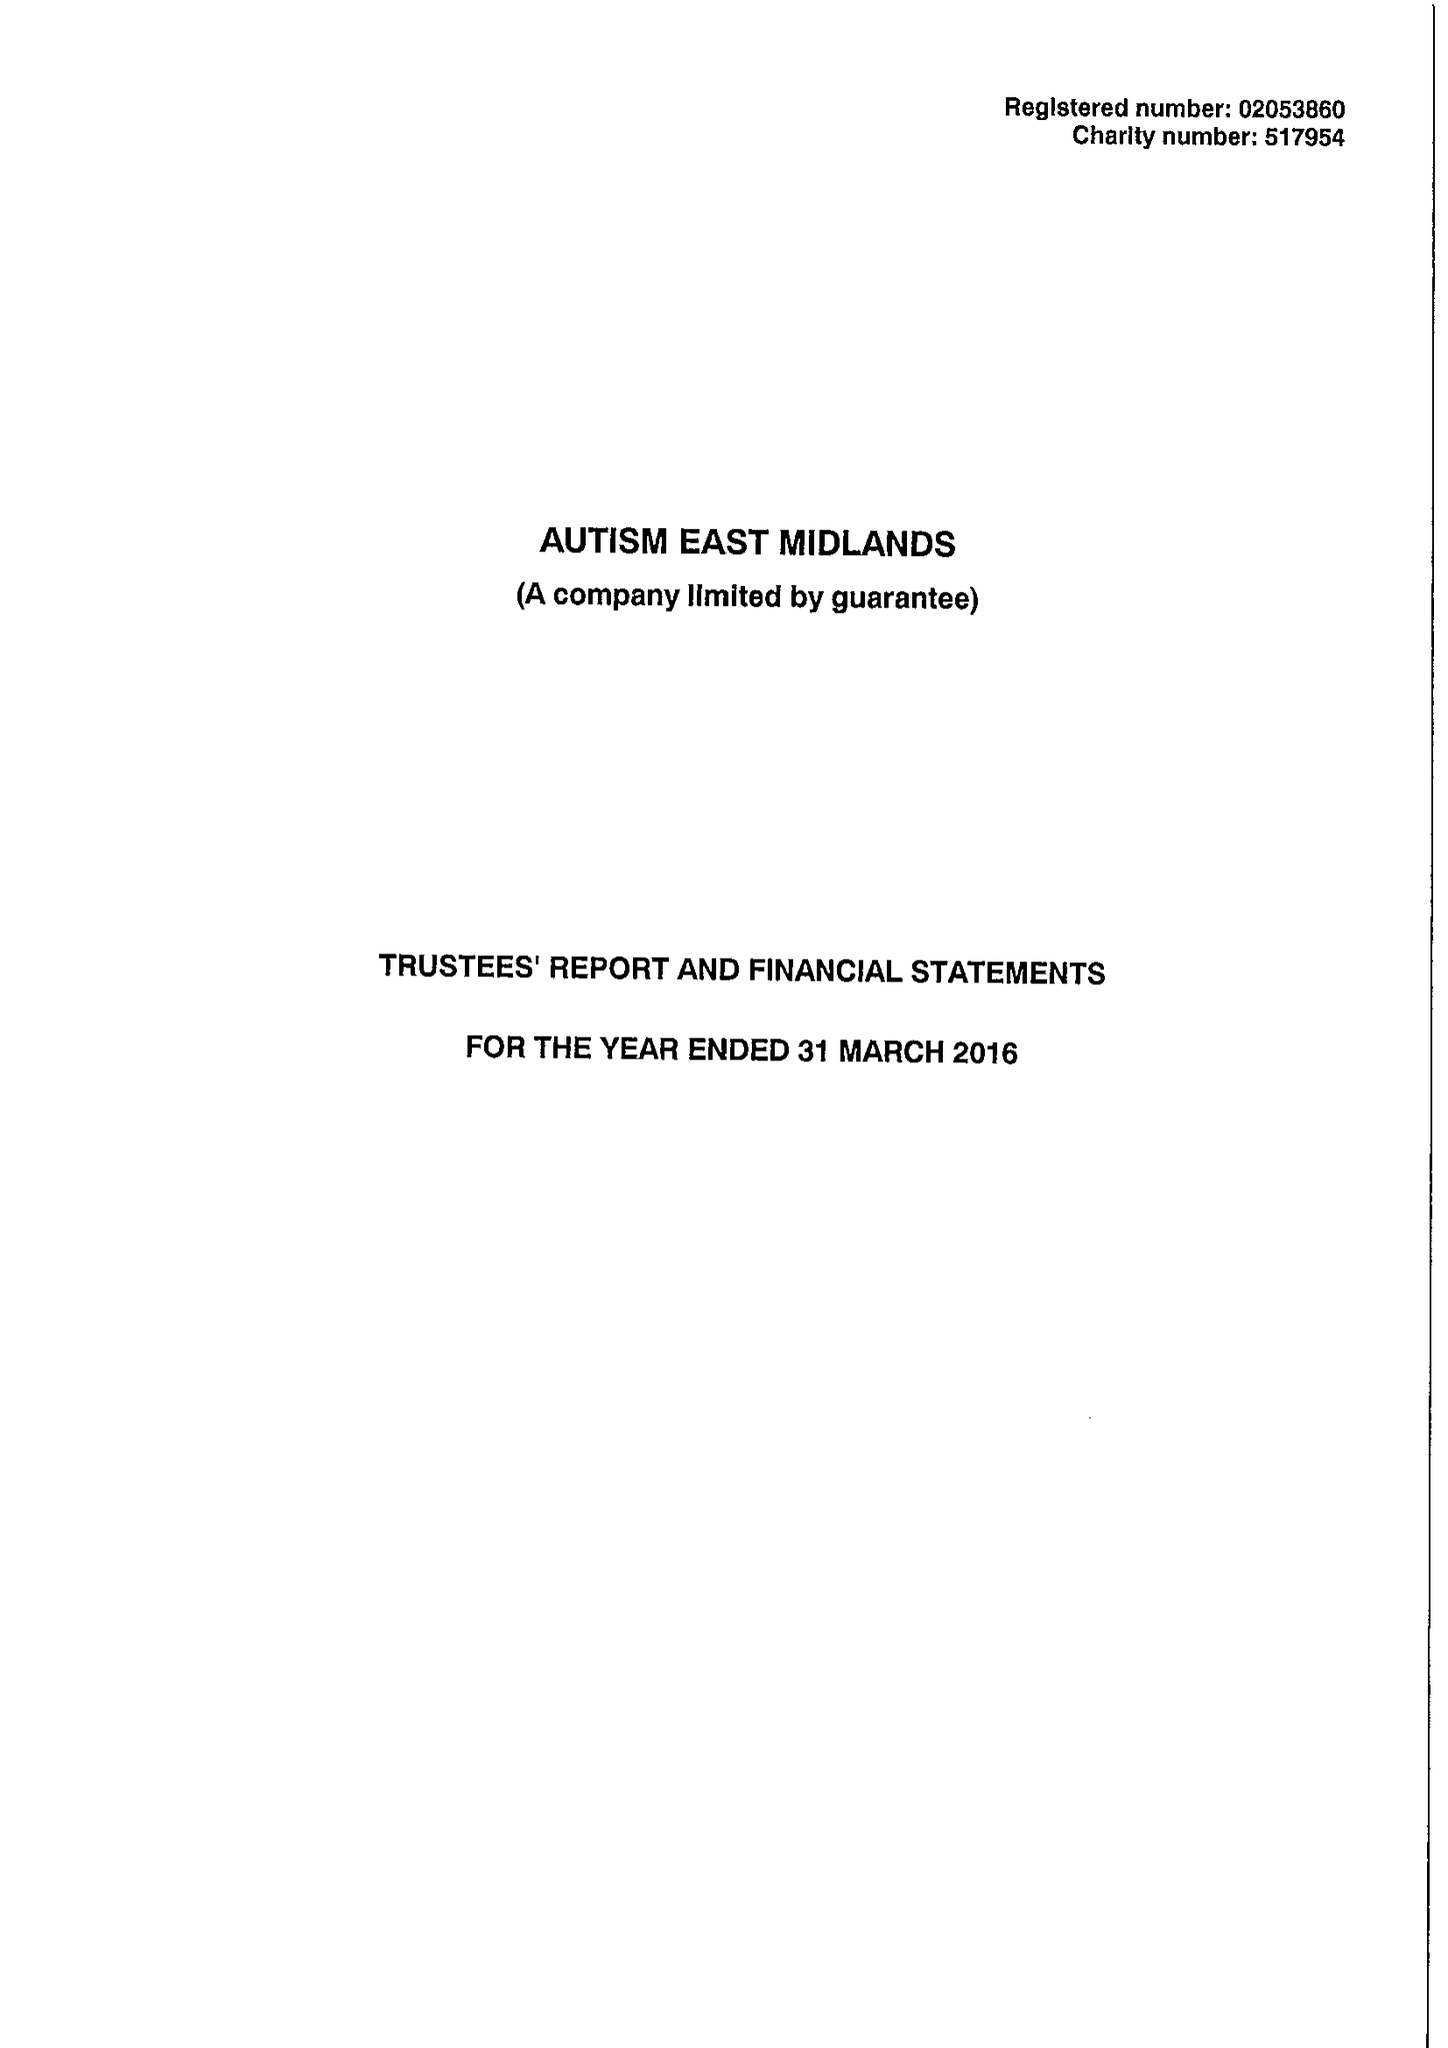What is the value for the address__street_line?
Answer the question using a single word or phrase. MORVEN STREET 